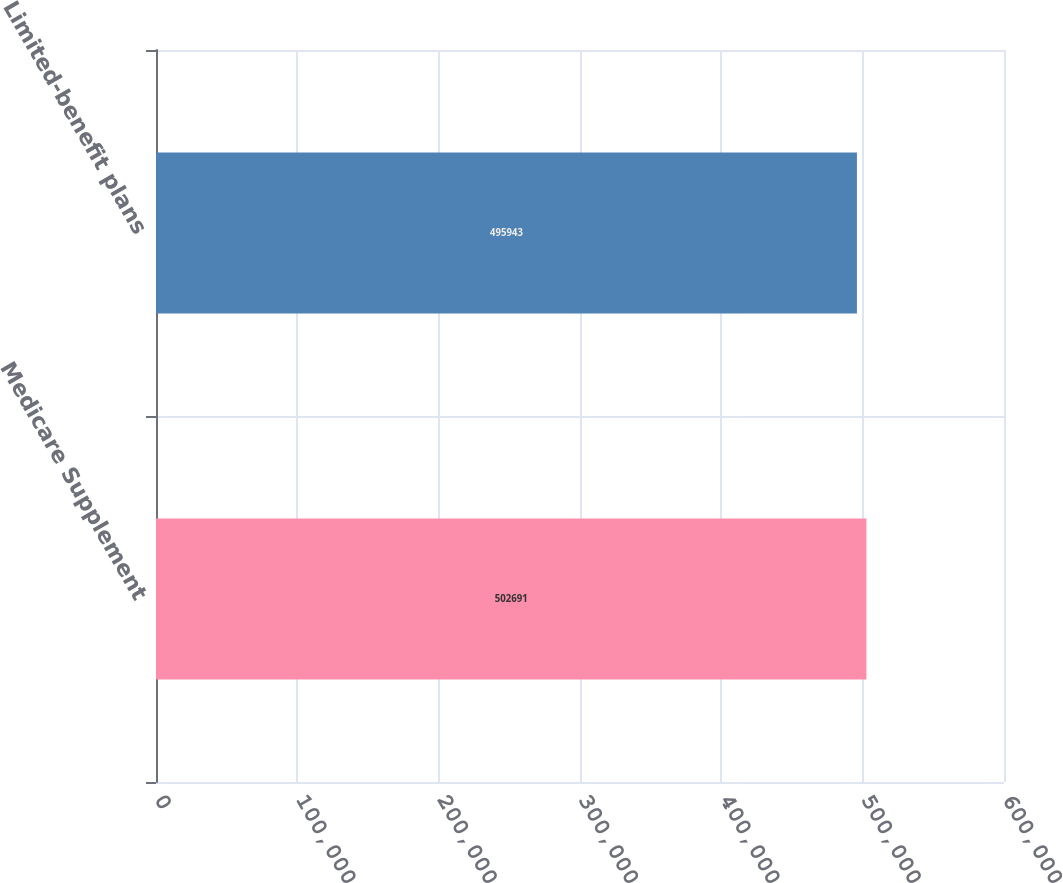Convert chart to OTSL. <chart><loc_0><loc_0><loc_500><loc_500><bar_chart><fcel>Medicare Supplement<fcel>Limited-benefit plans<nl><fcel>502691<fcel>495943<nl></chart> 